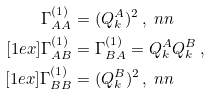Convert formula to latex. <formula><loc_0><loc_0><loc_500><loc_500>\Gamma ^ { ( 1 ) } _ { A A } & = ( Q _ { k } ^ { A } ) ^ { 2 } \, , \ n n \\ [ 1 e x ] \Gamma ^ { ( 1 ) } _ { A B } & = \Gamma ^ { ( 1 ) } _ { B A } = Q _ { k } ^ { A } Q _ { k } ^ { B } \, , \\ [ 1 e x ] \Gamma ^ { ( 1 ) } _ { B B } & = ( Q _ { k } ^ { B } ) ^ { 2 } \, , \ n n</formula> 